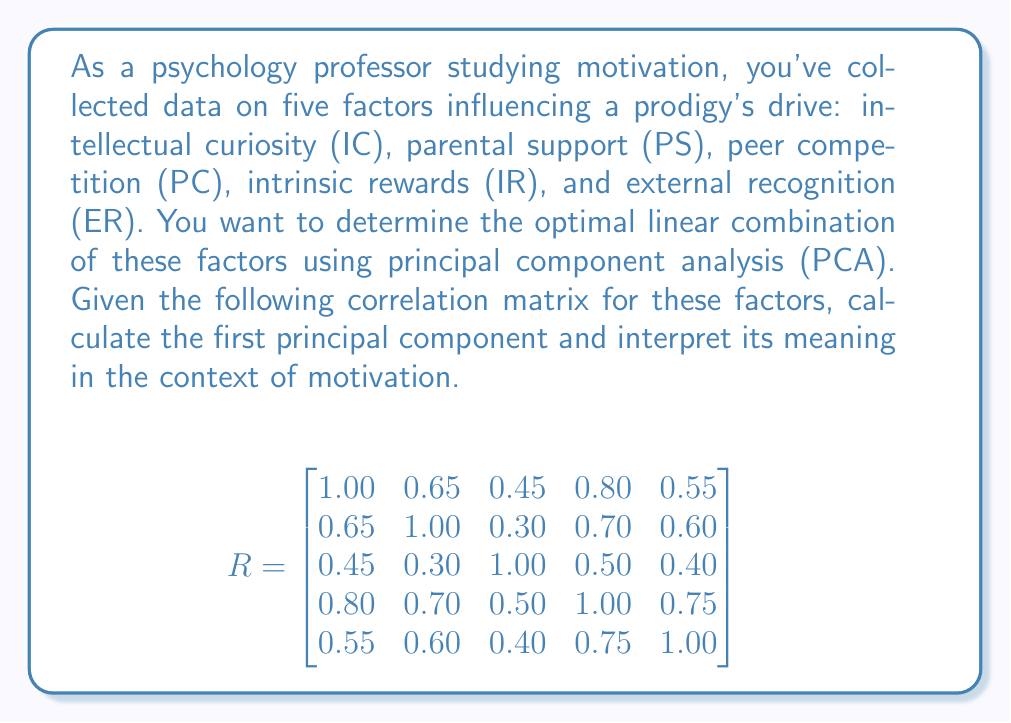Solve this math problem. To determine the first principal component using PCA:

1. Calculate the eigenvalues and eigenvectors of the correlation matrix R.

2. The largest eigenvalue corresponds to the first principal component, and its associated eigenvector gives the coefficients for the linear combination.

3. Using a mathematical software or calculator, we find the eigenvalues and eigenvectors:

   Largest eigenvalue: $\lambda_1 \approx 3.4722$
   
   Corresponding eigenvector: 
   $$v_1 \approx \begin{bmatrix} 0.4645 \\ 0.4438 \\ 0.3218 \\ 0.5114 \\ 0.4593 \end{bmatrix}$$

4. The first principal component (PC1) is the linear combination:

   PC1 = 0.4645(IC) + 0.4438(PS) + 0.3218(PC) + 0.5114(IR) + 0.4593(ER)

5. Interpretation:
   - All coefficients are positive, indicating that all factors contribute positively to the prodigy's motivation.
   - Intrinsic rewards (IR) has the highest coefficient (0.5114), suggesting it's the most influential factor.
   - Intellectual curiosity (IC) and external recognition (ER) follow closely in importance.
   - Peer competition (PC) has the lowest coefficient, indicating it's the least influential among these factors.

6. This principal component explains approximately 69.44% (3.4722/5) of the total variance in the data, representing a significant portion of the motivation factors.
Answer: PC1 = 0.4645(IC) + 0.4438(PS) + 0.3218(PC) + 0.5114(IR) + 0.4593(ER) 